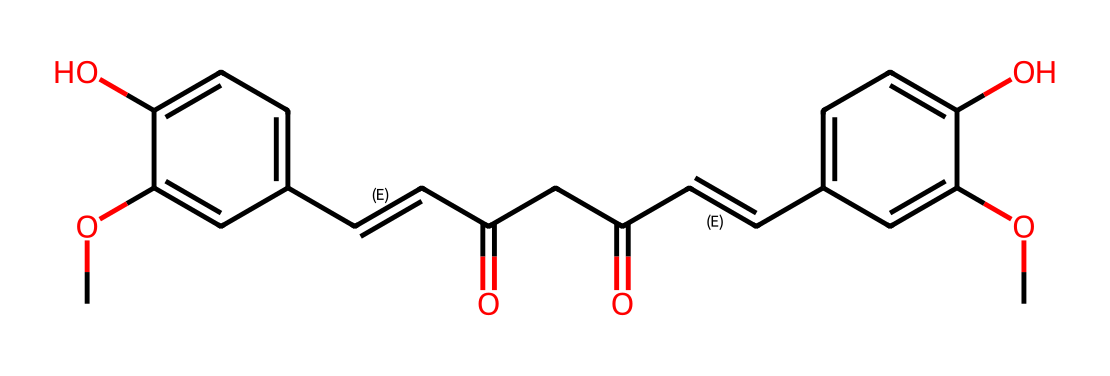What is the molecular formula of curcumin? By analyzing the SMILES representation, we can count the number of each type of atom. The count reveals there are 21 carbon (C) atoms, 20 hydrogen (H) atoms, and 6 oxygen (O) atoms, which leads us to the molecular formula C21H20O6.
Answer: C21H20O6 How many hydroxyl (-OH) groups are present in curcumin? Observing the structure from the SMILES notation, we can identify the -OH functional groups. There are two instances of -OH in the aromatic rings of curcumin. Therefore, the count of hydroxyl groups is 2.
Answer: 2 What type of functional groups are found in curcumin? In examining the structure, we can identify several functional groups: there are phenolic -OH groups, double bonds (alkenes) in the chain, and carbonyl (C=O) groups. Thus, the functional groups present are phenolic, alkene, and carbonyl.
Answer: phenolic, alkene, carbonyl What type of antioxidant properties does curcumin predominantly exhibit? Curcumin primarily exhibits scavenging properties and helps in chelating metal ions due to its phenolic structure, which is effective in reducing oxidative stress. This leads to its classification as a strong antioxidant.
Answer: scavenging How many rings are present in the curcumin structure? A close examination of the chemical structure reveals that there are two aromatic rings incorporated into the overall structure of curcumin. Each ring contributes to the compound's stability and its antioxidant activity.
Answer: 2 Which part of the molecule is responsible for antioxidant activity? The multiple hydroxyl (-OH) groups and the conjugated double bond system in curcumin create a resonance structure that stabilizes free radicals, thus enhancing its antioxidant properties.
Answer: hydroxyl groups and double bonds 